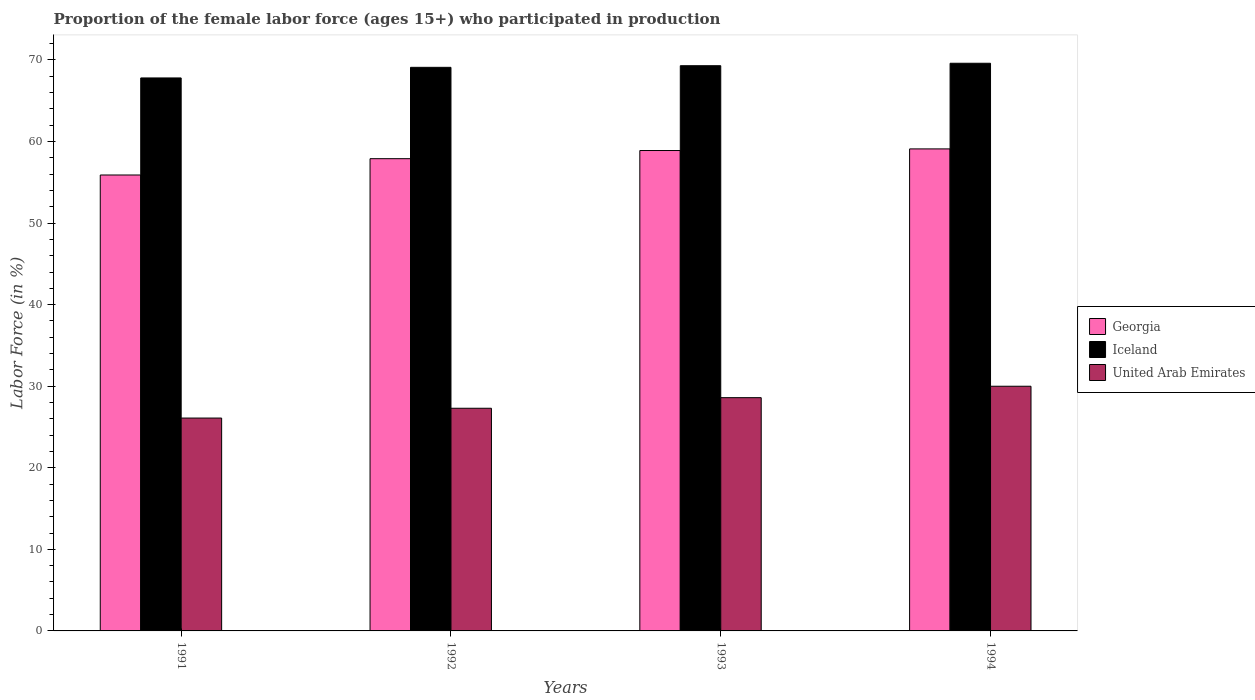How many groups of bars are there?
Offer a terse response. 4. Are the number of bars on each tick of the X-axis equal?
Ensure brevity in your answer.  Yes. What is the label of the 3rd group of bars from the left?
Keep it short and to the point. 1993. What is the proportion of the female labor force who participated in production in Georgia in 1994?
Your answer should be compact. 59.1. Across all years, what is the maximum proportion of the female labor force who participated in production in Georgia?
Offer a terse response. 59.1. Across all years, what is the minimum proportion of the female labor force who participated in production in Iceland?
Provide a succinct answer. 67.8. In which year was the proportion of the female labor force who participated in production in Georgia maximum?
Your answer should be compact. 1994. What is the total proportion of the female labor force who participated in production in Georgia in the graph?
Provide a short and direct response. 231.8. What is the difference between the proportion of the female labor force who participated in production in Iceland in 1992 and that in 1993?
Offer a terse response. -0.2. What is the difference between the proportion of the female labor force who participated in production in Georgia in 1993 and the proportion of the female labor force who participated in production in United Arab Emirates in 1994?
Offer a very short reply. 28.9. What is the average proportion of the female labor force who participated in production in Iceland per year?
Your answer should be very brief. 68.95. In the year 1991, what is the difference between the proportion of the female labor force who participated in production in Iceland and proportion of the female labor force who participated in production in United Arab Emirates?
Keep it short and to the point. 41.7. What is the ratio of the proportion of the female labor force who participated in production in Iceland in 1991 to that in 1993?
Offer a terse response. 0.98. Is the proportion of the female labor force who participated in production in United Arab Emirates in 1991 less than that in 1993?
Make the answer very short. Yes. What is the difference between the highest and the second highest proportion of the female labor force who participated in production in Georgia?
Provide a succinct answer. 0.2. What is the difference between the highest and the lowest proportion of the female labor force who participated in production in Iceland?
Give a very brief answer. 1.8. In how many years, is the proportion of the female labor force who participated in production in Georgia greater than the average proportion of the female labor force who participated in production in Georgia taken over all years?
Offer a terse response. 2. Is the sum of the proportion of the female labor force who participated in production in Iceland in 1991 and 1994 greater than the maximum proportion of the female labor force who participated in production in Georgia across all years?
Make the answer very short. Yes. What does the 2nd bar from the left in 1992 represents?
Provide a short and direct response. Iceland. What does the 1st bar from the right in 1994 represents?
Your answer should be very brief. United Arab Emirates. Is it the case that in every year, the sum of the proportion of the female labor force who participated in production in United Arab Emirates and proportion of the female labor force who participated in production in Georgia is greater than the proportion of the female labor force who participated in production in Iceland?
Your response must be concise. Yes. What is the difference between two consecutive major ticks on the Y-axis?
Give a very brief answer. 10. Are the values on the major ticks of Y-axis written in scientific E-notation?
Offer a very short reply. No. Does the graph contain any zero values?
Provide a succinct answer. No. Does the graph contain grids?
Give a very brief answer. No. Where does the legend appear in the graph?
Provide a short and direct response. Center right. How are the legend labels stacked?
Provide a short and direct response. Vertical. What is the title of the graph?
Offer a terse response. Proportion of the female labor force (ages 15+) who participated in production. What is the label or title of the X-axis?
Ensure brevity in your answer.  Years. What is the label or title of the Y-axis?
Make the answer very short. Labor Force (in %). What is the Labor Force (in %) in Georgia in 1991?
Offer a very short reply. 55.9. What is the Labor Force (in %) of Iceland in 1991?
Give a very brief answer. 67.8. What is the Labor Force (in %) of United Arab Emirates in 1991?
Keep it short and to the point. 26.1. What is the Labor Force (in %) of Georgia in 1992?
Offer a terse response. 57.9. What is the Labor Force (in %) in Iceland in 1992?
Offer a very short reply. 69.1. What is the Labor Force (in %) of United Arab Emirates in 1992?
Provide a succinct answer. 27.3. What is the Labor Force (in %) of Georgia in 1993?
Offer a terse response. 58.9. What is the Labor Force (in %) in Iceland in 1993?
Your answer should be compact. 69.3. What is the Labor Force (in %) in United Arab Emirates in 1993?
Make the answer very short. 28.6. What is the Labor Force (in %) in Georgia in 1994?
Keep it short and to the point. 59.1. What is the Labor Force (in %) in Iceland in 1994?
Your response must be concise. 69.6. What is the Labor Force (in %) in United Arab Emirates in 1994?
Make the answer very short. 30. Across all years, what is the maximum Labor Force (in %) of Georgia?
Provide a succinct answer. 59.1. Across all years, what is the maximum Labor Force (in %) in Iceland?
Offer a terse response. 69.6. Across all years, what is the maximum Labor Force (in %) in United Arab Emirates?
Make the answer very short. 30. Across all years, what is the minimum Labor Force (in %) of Georgia?
Provide a short and direct response. 55.9. Across all years, what is the minimum Labor Force (in %) in Iceland?
Your answer should be compact. 67.8. Across all years, what is the minimum Labor Force (in %) in United Arab Emirates?
Ensure brevity in your answer.  26.1. What is the total Labor Force (in %) in Georgia in the graph?
Offer a very short reply. 231.8. What is the total Labor Force (in %) in Iceland in the graph?
Your response must be concise. 275.8. What is the total Labor Force (in %) in United Arab Emirates in the graph?
Your answer should be compact. 112. What is the difference between the Labor Force (in %) of Georgia in 1991 and that in 1992?
Provide a short and direct response. -2. What is the difference between the Labor Force (in %) of United Arab Emirates in 1991 and that in 1992?
Provide a succinct answer. -1.2. What is the difference between the Labor Force (in %) of Georgia in 1991 and that in 1993?
Keep it short and to the point. -3. What is the difference between the Labor Force (in %) in Georgia in 1991 and that in 1994?
Ensure brevity in your answer.  -3.2. What is the difference between the Labor Force (in %) in Iceland in 1991 and that in 1994?
Give a very brief answer. -1.8. What is the difference between the Labor Force (in %) in United Arab Emirates in 1991 and that in 1994?
Your response must be concise. -3.9. What is the difference between the Labor Force (in %) of Georgia in 1992 and that in 1993?
Give a very brief answer. -1. What is the difference between the Labor Force (in %) in Iceland in 1992 and that in 1993?
Keep it short and to the point. -0.2. What is the difference between the Labor Force (in %) of Georgia in 1992 and that in 1994?
Offer a very short reply. -1.2. What is the difference between the Labor Force (in %) of Iceland in 1992 and that in 1994?
Ensure brevity in your answer.  -0.5. What is the difference between the Labor Force (in %) in Georgia in 1993 and that in 1994?
Your answer should be very brief. -0.2. What is the difference between the Labor Force (in %) of Iceland in 1993 and that in 1994?
Give a very brief answer. -0.3. What is the difference between the Labor Force (in %) in Georgia in 1991 and the Labor Force (in %) in United Arab Emirates in 1992?
Your response must be concise. 28.6. What is the difference between the Labor Force (in %) in Iceland in 1991 and the Labor Force (in %) in United Arab Emirates in 1992?
Provide a short and direct response. 40.5. What is the difference between the Labor Force (in %) of Georgia in 1991 and the Labor Force (in %) of United Arab Emirates in 1993?
Keep it short and to the point. 27.3. What is the difference between the Labor Force (in %) of Iceland in 1991 and the Labor Force (in %) of United Arab Emirates in 1993?
Your answer should be very brief. 39.2. What is the difference between the Labor Force (in %) of Georgia in 1991 and the Labor Force (in %) of Iceland in 1994?
Give a very brief answer. -13.7. What is the difference between the Labor Force (in %) of Georgia in 1991 and the Labor Force (in %) of United Arab Emirates in 1994?
Provide a short and direct response. 25.9. What is the difference between the Labor Force (in %) of Iceland in 1991 and the Labor Force (in %) of United Arab Emirates in 1994?
Provide a succinct answer. 37.8. What is the difference between the Labor Force (in %) of Georgia in 1992 and the Labor Force (in %) of Iceland in 1993?
Provide a succinct answer. -11.4. What is the difference between the Labor Force (in %) of Georgia in 1992 and the Labor Force (in %) of United Arab Emirates in 1993?
Provide a short and direct response. 29.3. What is the difference between the Labor Force (in %) of Iceland in 1992 and the Labor Force (in %) of United Arab Emirates in 1993?
Your answer should be very brief. 40.5. What is the difference between the Labor Force (in %) in Georgia in 1992 and the Labor Force (in %) in United Arab Emirates in 1994?
Your response must be concise. 27.9. What is the difference between the Labor Force (in %) of Iceland in 1992 and the Labor Force (in %) of United Arab Emirates in 1994?
Provide a short and direct response. 39.1. What is the difference between the Labor Force (in %) in Georgia in 1993 and the Labor Force (in %) in Iceland in 1994?
Keep it short and to the point. -10.7. What is the difference between the Labor Force (in %) in Georgia in 1993 and the Labor Force (in %) in United Arab Emirates in 1994?
Offer a very short reply. 28.9. What is the difference between the Labor Force (in %) of Iceland in 1993 and the Labor Force (in %) of United Arab Emirates in 1994?
Your response must be concise. 39.3. What is the average Labor Force (in %) of Georgia per year?
Make the answer very short. 57.95. What is the average Labor Force (in %) in Iceland per year?
Your answer should be compact. 68.95. What is the average Labor Force (in %) in United Arab Emirates per year?
Your answer should be very brief. 28. In the year 1991, what is the difference between the Labor Force (in %) of Georgia and Labor Force (in %) of United Arab Emirates?
Offer a very short reply. 29.8. In the year 1991, what is the difference between the Labor Force (in %) in Iceland and Labor Force (in %) in United Arab Emirates?
Provide a succinct answer. 41.7. In the year 1992, what is the difference between the Labor Force (in %) of Georgia and Labor Force (in %) of Iceland?
Give a very brief answer. -11.2. In the year 1992, what is the difference between the Labor Force (in %) in Georgia and Labor Force (in %) in United Arab Emirates?
Make the answer very short. 30.6. In the year 1992, what is the difference between the Labor Force (in %) in Iceland and Labor Force (in %) in United Arab Emirates?
Your answer should be very brief. 41.8. In the year 1993, what is the difference between the Labor Force (in %) of Georgia and Labor Force (in %) of Iceland?
Offer a terse response. -10.4. In the year 1993, what is the difference between the Labor Force (in %) in Georgia and Labor Force (in %) in United Arab Emirates?
Provide a short and direct response. 30.3. In the year 1993, what is the difference between the Labor Force (in %) of Iceland and Labor Force (in %) of United Arab Emirates?
Provide a succinct answer. 40.7. In the year 1994, what is the difference between the Labor Force (in %) in Georgia and Labor Force (in %) in Iceland?
Offer a very short reply. -10.5. In the year 1994, what is the difference between the Labor Force (in %) of Georgia and Labor Force (in %) of United Arab Emirates?
Provide a succinct answer. 29.1. In the year 1994, what is the difference between the Labor Force (in %) of Iceland and Labor Force (in %) of United Arab Emirates?
Ensure brevity in your answer.  39.6. What is the ratio of the Labor Force (in %) in Georgia in 1991 to that in 1992?
Keep it short and to the point. 0.97. What is the ratio of the Labor Force (in %) in Iceland in 1991 to that in 1992?
Your answer should be very brief. 0.98. What is the ratio of the Labor Force (in %) in United Arab Emirates in 1991 to that in 1992?
Give a very brief answer. 0.96. What is the ratio of the Labor Force (in %) in Georgia in 1991 to that in 1993?
Provide a short and direct response. 0.95. What is the ratio of the Labor Force (in %) of Iceland in 1991 to that in 1993?
Provide a short and direct response. 0.98. What is the ratio of the Labor Force (in %) in United Arab Emirates in 1991 to that in 1993?
Give a very brief answer. 0.91. What is the ratio of the Labor Force (in %) in Georgia in 1991 to that in 1994?
Offer a terse response. 0.95. What is the ratio of the Labor Force (in %) of Iceland in 1991 to that in 1994?
Keep it short and to the point. 0.97. What is the ratio of the Labor Force (in %) of United Arab Emirates in 1991 to that in 1994?
Ensure brevity in your answer.  0.87. What is the ratio of the Labor Force (in %) in Georgia in 1992 to that in 1993?
Give a very brief answer. 0.98. What is the ratio of the Labor Force (in %) in Iceland in 1992 to that in 1993?
Ensure brevity in your answer.  1. What is the ratio of the Labor Force (in %) in United Arab Emirates in 1992 to that in 1993?
Your answer should be very brief. 0.95. What is the ratio of the Labor Force (in %) in Georgia in 1992 to that in 1994?
Give a very brief answer. 0.98. What is the ratio of the Labor Force (in %) of Iceland in 1992 to that in 1994?
Give a very brief answer. 0.99. What is the ratio of the Labor Force (in %) of United Arab Emirates in 1992 to that in 1994?
Provide a short and direct response. 0.91. What is the ratio of the Labor Force (in %) in Georgia in 1993 to that in 1994?
Your answer should be very brief. 1. What is the ratio of the Labor Force (in %) of United Arab Emirates in 1993 to that in 1994?
Ensure brevity in your answer.  0.95. What is the difference between the highest and the second highest Labor Force (in %) in Georgia?
Give a very brief answer. 0.2. What is the difference between the highest and the lowest Labor Force (in %) of Iceland?
Your answer should be compact. 1.8. What is the difference between the highest and the lowest Labor Force (in %) in United Arab Emirates?
Ensure brevity in your answer.  3.9. 